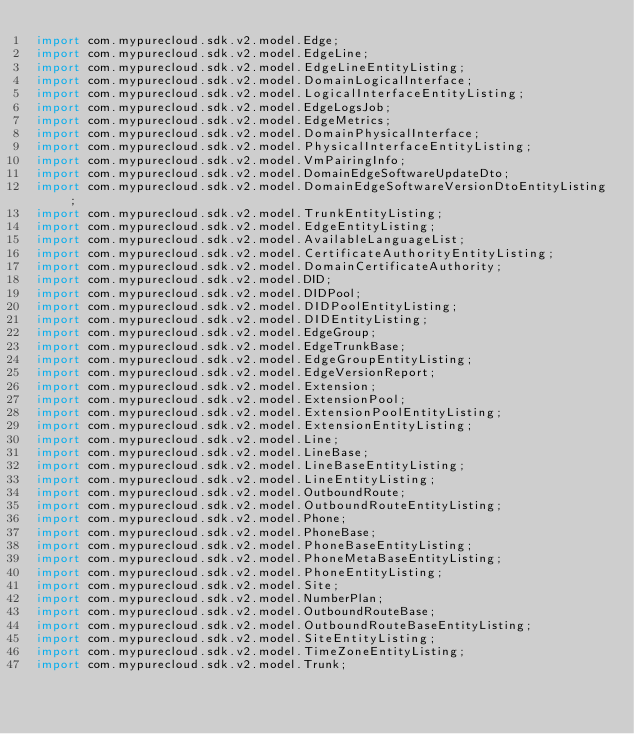<code> <loc_0><loc_0><loc_500><loc_500><_Java_>import com.mypurecloud.sdk.v2.model.Edge;
import com.mypurecloud.sdk.v2.model.EdgeLine;
import com.mypurecloud.sdk.v2.model.EdgeLineEntityListing;
import com.mypurecloud.sdk.v2.model.DomainLogicalInterface;
import com.mypurecloud.sdk.v2.model.LogicalInterfaceEntityListing;
import com.mypurecloud.sdk.v2.model.EdgeLogsJob;
import com.mypurecloud.sdk.v2.model.EdgeMetrics;
import com.mypurecloud.sdk.v2.model.DomainPhysicalInterface;
import com.mypurecloud.sdk.v2.model.PhysicalInterfaceEntityListing;
import com.mypurecloud.sdk.v2.model.VmPairingInfo;
import com.mypurecloud.sdk.v2.model.DomainEdgeSoftwareUpdateDto;
import com.mypurecloud.sdk.v2.model.DomainEdgeSoftwareVersionDtoEntityListing;
import com.mypurecloud.sdk.v2.model.TrunkEntityListing;
import com.mypurecloud.sdk.v2.model.EdgeEntityListing;
import com.mypurecloud.sdk.v2.model.AvailableLanguageList;
import com.mypurecloud.sdk.v2.model.CertificateAuthorityEntityListing;
import com.mypurecloud.sdk.v2.model.DomainCertificateAuthority;
import com.mypurecloud.sdk.v2.model.DID;
import com.mypurecloud.sdk.v2.model.DIDPool;
import com.mypurecloud.sdk.v2.model.DIDPoolEntityListing;
import com.mypurecloud.sdk.v2.model.DIDEntityListing;
import com.mypurecloud.sdk.v2.model.EdgeGroup;
import com.mypurecloud.sdk.v2.model.EdgeTrunkBase;
import com.mypurecloud.sdk.v2.model.EdgeGroupEntityListing;
import com.mypurecloud.sdk.v2.model.EdgeVersionReport;
import com.mypurecloud.sdk.v2.model.Extension;
import com.mypurecloud.sdk.v2.model.ExtensionPool;
import com.mypurecloud.sdk.v2.model.ExtensionPoolEntityListing;
import com.mypurecloud.sdk.v2.model.ExtensionEntityListing;
import com.mypurecloud.sdk.v2.model.Line;
import com.mypurecloud.sdk.v2.model.LineBase;
import com.mypurecloud.sdk.v2.model.LineBaseEntityListing;
import com.mypurecloud.sdk.v2.model.LineEntityListing;
import com.mypurecloud.sdk.v2.model.OutboundRoute;
import com.mypurecloud.sdk.v2.model.OutboundRouteEntityListing;
import com.mypurecloud.sdk.v2.model.Phone;
import com.mypurecloud.sdk.v2.model.PhoneBase;
import com.mypurecloud.sdk.v2.model.PhoneBaseEntityListing;
import com.mypurecloud.sdk.v2.model.PhoneMetaBaseEntityListing;
import com.mypurecloud.sdk.v2.model.PhoneEntityListing;
import com.mypurecloud.sdk.v2.model.Site;
import com.mypurecloud.sdk.v2.model.NumberPlan;
import com.mypurecloud.sdk.v2.model.OutboundRouteBase;
import com.mypurecloud.sdk.v2.model.OutboundRouteBaseEntityListing;
import com.mypurecloud.sdk.v2.model.SiteEntityListing;
import com.mypurecloud.sdk.v2.model.TimeZoneEntityListing;
import com.mypurecloud.sdk.v2.model.Trunk;</code> 